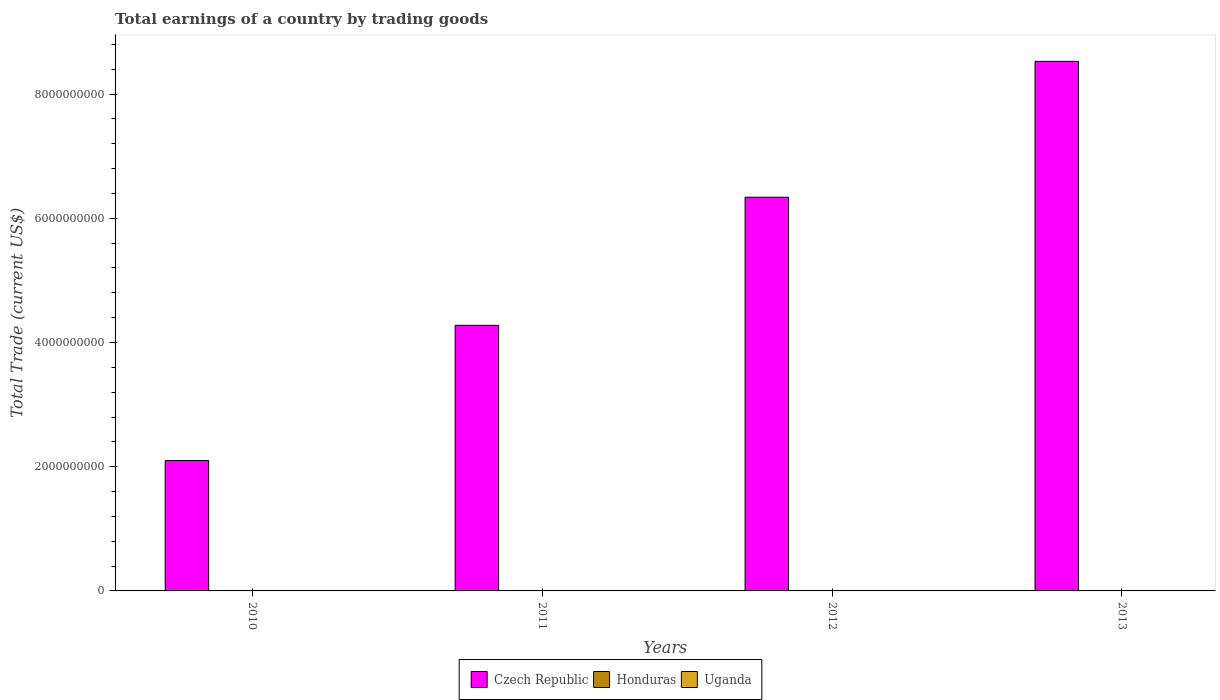How many different coloured bars are there?
Give a very brief answer. 1. Are the number of bars per tick equal to the number of legend labels?
Provide a succinct answer. No. How many bars are there on the 2nd tick from the left?
Give a very brief answer. 1. How many bars are there on the 3rd tick from the right?
Ensure brevity in your answer.  1. What is the label of the 3rd group of bars from the left?
Keep it short and to the point. 2012. What is the total earnings in Honduras in 2013?
Provide a succinct answer. 0. Across all years, what is the maximum total earnings in Czech Republic?
Your response must be concise. 8.53e+09. Across all years, what is the minimum total earnings in Czech Republic?
Ensure brevity in your answer.  2.10e+09. What is the difference between the total earnings in Czech Republic in 2012 and that in 2013?
Make the answer very short. -2.19e+09. What is the difference between the total earnings in Uganda in 2010 and the total earnings in Czech Republic in 2013?
Provide a short and direct response. -8.53e+09. What is the average total earnings in Uganda per year?
Provide a succinct answer. 0. In how many years, is the total earnings in Uganda greater than 8000000000 US$?
Your response must be concise. 0. What is the ratio of the total earnings in Czech Republic in 2010 to that in 2011?
Offer a terse response. 0.49. What is the difference between the highest and the second highest total earnings in Czech Republic?
Your answer should be very brief. 2.19e+09. In how many years, is the total earnings in Uganda greater than the average total earnings in Uganda taken over all years?
Your answer should be very brief. 0. Is it the case that in every year, the sum of the total earnings in Honduras and total earnings in Czech Republic is greater than the total earnings in Uganda?
Offer a terse response. Yes. How many bars are there?
Keep it short and to the point. 4. Are all the bars in the graph horizontal?
Your answer should be very brief. No. What is the difference between two consecutive major ticks on the Y-axis?
Your response must be concise. 2.00e+09. Does the graph contain any zero values?
Give a very brief answer. Yes. How many legend labels are there?
Provide a short and direct response. 3. How are the legend labels stacked?
Your response must be concise. Horizontal. What is the title of the graph?
Keep it short and to the point. Total earnings of a country by trading goods. What is the label or title of the X-axis?
Provide a succinct answer. Years. What is the label or title of the Y-axis?
Ensure brevity in your answer.  Total Trade (current US$). What is the Total Trade (current US$) in Czech Republic in 2010?
Ensure brevity in your answer.  2.10e+09. What is the Total Trade (current US$) in Czech Republic in 2011?
Offer a terse response. 4.28e+09. What is the Total Trade (current US$) of Honduras in 2011?
Your response must be concise. 0. What is the Total Trade (current US$) in Uganda in 2011?
Ensure brevity in your answer.  0. What is the Total Trade (current US$) of Czech Republic in 2012?
Your answer should be compact. 6.34e+09. What is the Total Trade (current US$) of Czech Republic in 2013?
Ensure brevity in your answer.  8.53e+09. What is the Total Trade (current US$) in Honduras in 2013?
Keep it short and to the point. 0. What is the Total Trade (current US$) in Uganda in 2013?
Ensure brevity in your answer.  0. Across all years, what is the maximum Total Trade (current US$) of Czech Republic?
Your answer should be very brief. 8.53e+09. Across all years, what is the minimum Total Trade (current US$) in Czech Republic?
Offer a very short reply. 2.10e+09. What is the total Total Trade (current US$) in Czech Republic in the graph?
Keep it short and to the point. 2.12e+1. What is the difference between the Total Trade (current US$) of Czech Republic in 2010 and that in 2011?
Ensure brevity in your answer.  -2.18e+09. What is the difference between the Total Trade (current US$) in Czech Republic in 2010 and that in 2012?
Provide a short and direct response. -4.24e+09. What is the difference between the Total Trade (current US$) in Czech Republic in 2010 and that in 2013?
Ensure brevity in your answer.  -6.43e+09. What is the difference between the Total Trade (current US$) of Czech Republic in 2011 and that in 2012?
Provide a short and direct response. -2.06e+09. What is the difference between the Total Trade (current US$) in Czech Republic in 2011 and that in 2013?
Your answer should be compact. -4.25e+09. What is the difference between the Total Trade (current US$) of Czech Republic in 2012 and that in 2013?
Your answer should be compact. -2.19e+09. What is the average Total Trade (current US$) of Czech Republic per year?
Give a very brief answer. 5.31e+09. What is the ratio of the Total Trade (current US$) in Czech Republic in 2010 to that in 2011?
Your answer should be compact. 0.49. What is the ratio of the Total Trade (current US$) in Czech Republic in 2010 to that in 2012?
Give a very brief answer. 0.33. What is the ratio of the Total Trade (current US$) of Czech Republic in 2010 to that in 2013?
Offer a terse response. 0.25. What is the ratio of the Total Trade (current US$) in Czech Republic in 2011 to that in 2012?
Ensure brevity in your answer.  0.67. What is the ratio of the Total Trade (current US$) in Czech Republic in 2011 to that in 2013?
Provide a short and direct response. 0.5. What is the ratio of the Total Trade (current US$) in Czech Republic in 2012 to that in 2013?
Make the answer very short. 0.74. What is the difference between the highest and the second highest Total Trade (current US$) of Czech Republic?
Make the answer very short. 2.19e+09. What is the difference between the highest and the lowest Total Trade (current US$) in Czech Republic?
Your answer should be very brief. 6.43e+09. 